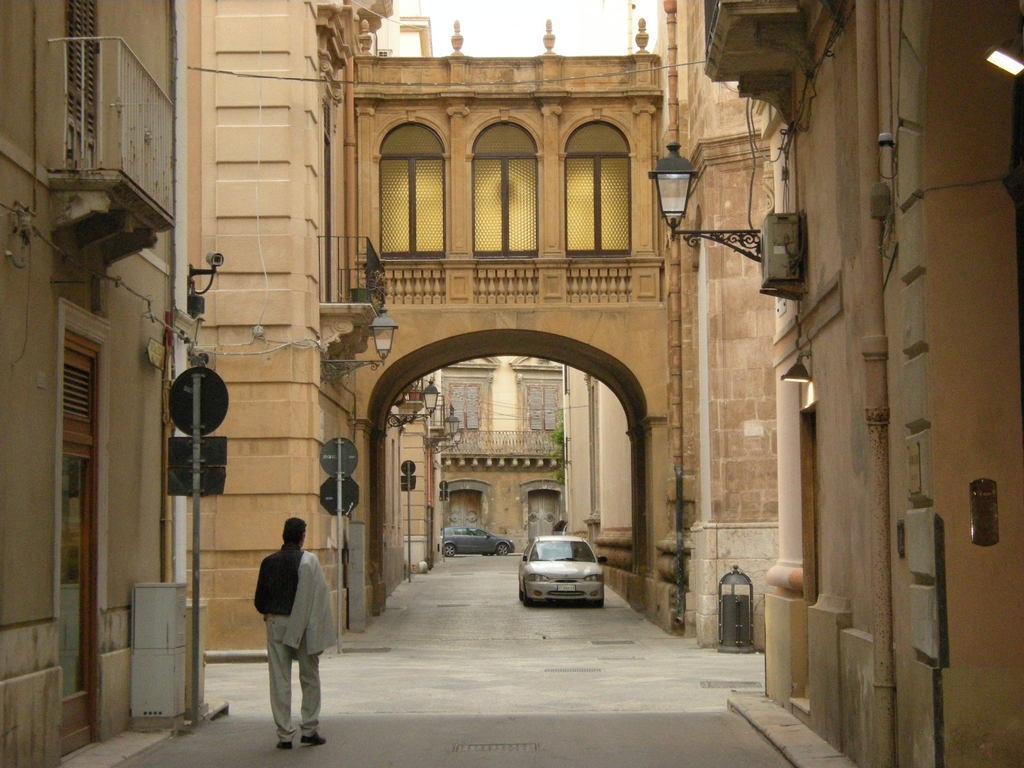Describe this image in one or two sentences. This is an outside view. At the bottom there are two cars on the road and one person is walking towards the back side. On both sides of the road, I can see the buildings. On the left side there are few poles. 